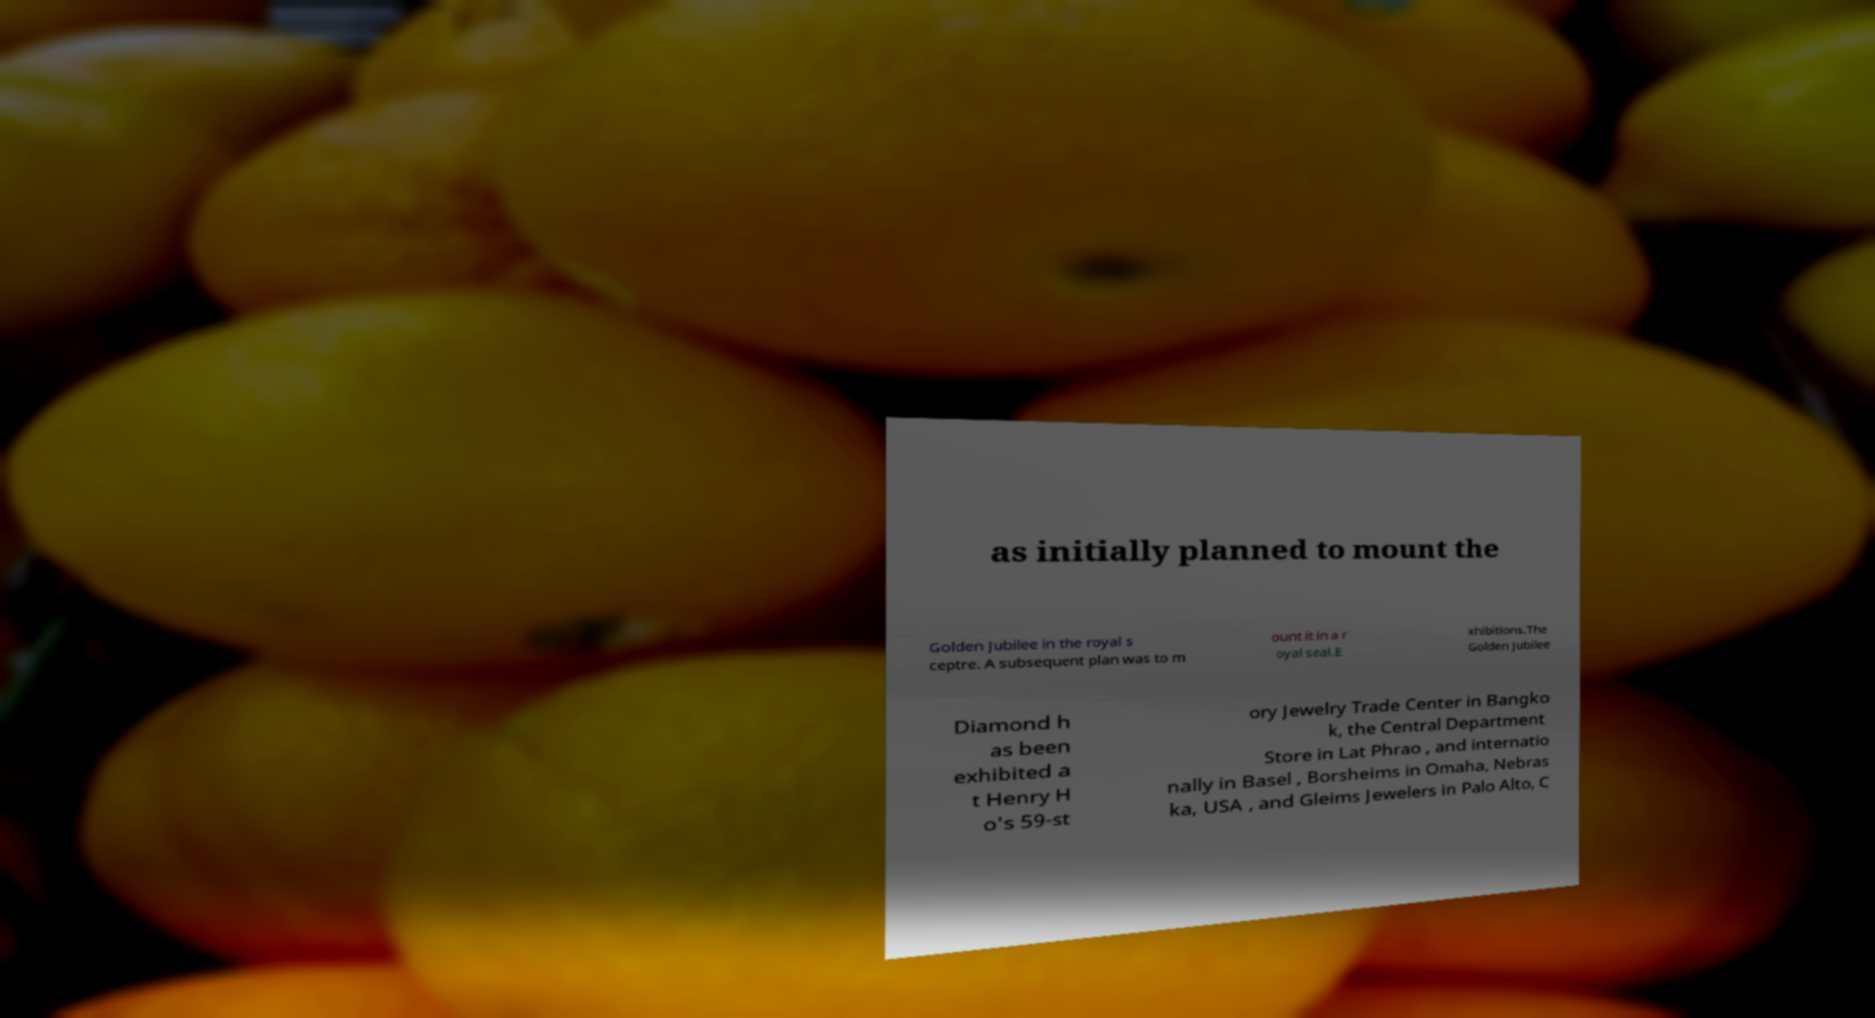What messages or text are displayed in this image? I need them in a readable, typed format. as initially planned to mount the Golden Jubilee in the royal s ceptre. A subsequent plan was to m ount it in a r oyal seal.E xhibitions.The Golden Jubilee Diamond h as been exhibited a t Henry H o's 59-st ory Jewelry Trade Center in Bangko k, the Central Department Store in Lat Phrao , and internatio nally in Basel , Borsheims in Omaha, Nebras ka, USA , and Gleims Jewelers in Palo Alto, C 